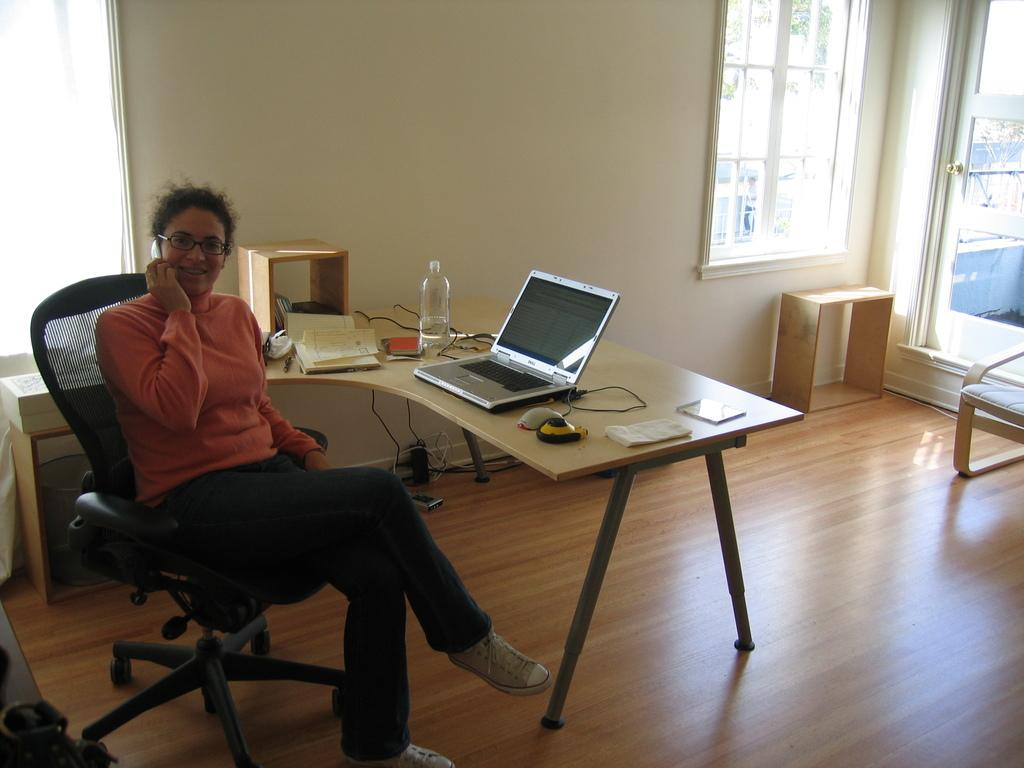What is the woman in the image doing? The woman is sitting in a chair and talking on a mobile phone. What objects can be seen on the table in the image? There is a laptop, a water bottle, and a book on the table. Can you describe the woman's activity in more detail? The woman is engaged in a conversation using her mobile phone. What is the purpose of the laptop on the table? The laptop's purpose is not specified in the image, but it could be used for work, browsing the internet, or other activities. What type of voyage is the woman planning based on the items on the table? There is no indication of a voyage in the image, as the items on the table are a laptop, a water bottle, and a book. What vein is visible on the woman's arm in the image? There is no visible vein on the woman's arm in the image, nor is there any reference to a vein in the provided facts. 